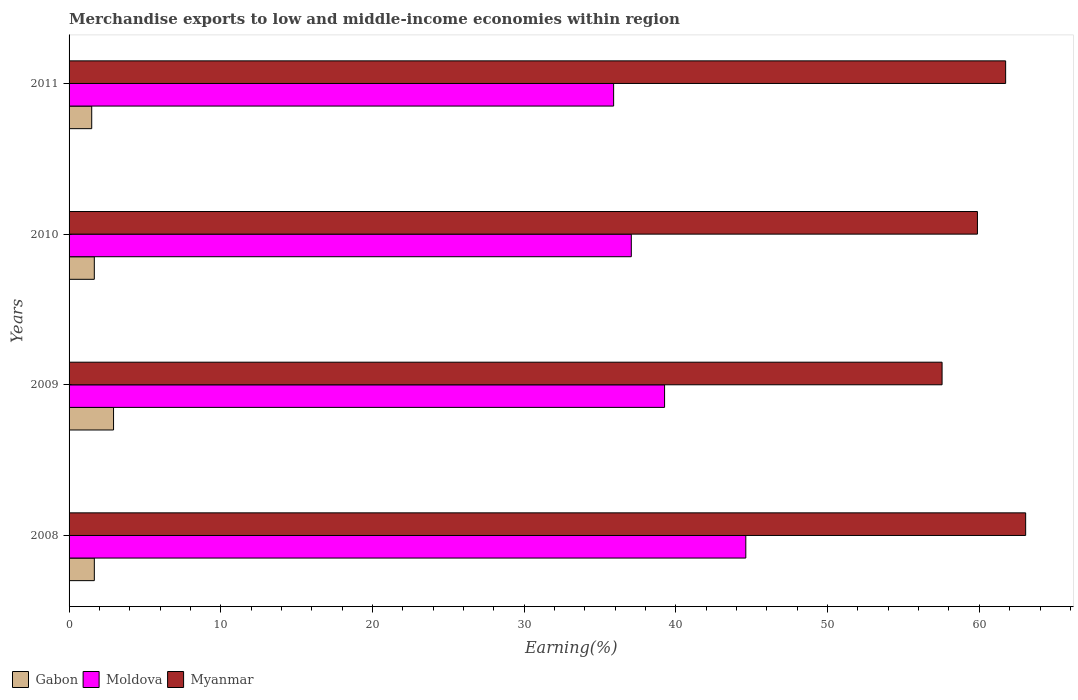How many different coloured bars are there?
Offer a terse response. 3. How many groups of bars are there?
Keep it short and to the point. 4. Are the number of bars per tick equal to the number of legend labels?
Give a very brief answer. Yes. How many bars are there on the 3rd tick from the top?
Keep it short and to the point. 3. In how many cases, is the number of bars for a given year not equal to the number of legend labels?
Give a very brief answer. 0. What is the percentage of amount earned from merchandise exports in Gabon in 2010?
Make the answer very short. 1.66. Across all years, what is the maximum percentage of amount earned from merchandise exports in Moldova?
Offer a terse response. 44.61. Across all years, what is the minimum percentage of amount earned from merchandise exports in Moldova?
Keep it short and to the point. 35.89. In which year was the percentage of amount earned from merchandise exports in Gabon minimum?
Provide a succinct answer. 2011. What is the total percentage of amount earned from merchandise exports in Myanmar in the graph?
Your response must be concise. 242.21. What is the difference between the percentage of amount earned from merchandise exports in Gabon in 2009 and that in 2011?
Keep it short and to the point. 1.44. What is the difference between the percentage of amount earned from merchandise exports in Moldova in 2010 and the percentage of amount earned from merchandise exports in Myanmar in 2011?
Your response must be concise. -24.67. What is the average percentage of amount earned from merchandise exports in Moldova per year?
Provide a succinct answer. 39.2. In the year 2009, what is the difference between the percentage of amount earned from merchandise exports in Gabon and percentage of amount earned from merchandise exports in Myanmar?
Make the answer very short. -54.61. What is the ratio of the percentage of amount earned from merchandise exports in Moldova in 2008 to that in 2009?
Provide a short and direct response. 1.14. Is the difference between the percentage of amount earned from merchandise exports in Gabon in 2008 and 2010 greater than the difference between the percentage of amount earned from merchandise exports in Myanmar in 2008 and 2010?
Your answer should be compact. No. What is the difference between the highest and the second highest percentage of amount earned from merchandise exports in Moldova?
Keep it short and to the point. 5.36. What is the difference between the highest and the lowest percentage of amount earned from merchandise exports in Myanmar?
Give a very brief answer. 5.51. In how many years, is the percentage of amount earned from merchandise exports in Gabon greater than the average percentage of amount earned from merchandise exports in Gabon taken over all years?
Offer a terse response. 1. What does the 2nd bar from the top in 2011 represents?
Provide a succinct answer. Moldova. What does the 2nd bar from the bottom in 2009 represents?
Make the answer very short. Moldova. Are all the bars in the graph horizontal?
Offer a terse response. Yes. How many years are there in the graph?
Your answer should be compact. 4. What is the difference between two consecutive major ticks on the X-axis?
Provide a short and direct response. 10. Are the values on the major ticks of X-axis written in scientific E-notation?
Ensure brevity in your answer.  No. Does the graph contain any zero values?
Provide a succinct answer. No. Does the graph contain grids?
Your response must be concise. No. Where does the legend appear in the graph?
Offer a very short reply. Bottom left. How many legend labels are there?
Provide a succinct answer. 3. What is the title of the graph?
Provide a succinct answer. Merchandise exports to low and middle-income economies within region. Does "Peru" appear as one of the legend labels in the graph?
Provide a succinct answer. No. What is the label or title of the X-axis?
Make the answer very short. Earning(%). What is the label or title of the Y-axis?
Make the answer very short. Years. What is the Earning(%) in Gabon in 2008?
Ensure brevity in your answer.  1.67. What is the Earning(%) in Moldova in 2008?
Offer a terse response. 44.61. What is the Earning(%) in Myanmar in 2008?
Provide a short and direct response. 63.05. What is the Earning(%) of Gabon in 2009?
Your response must be concise. 2.93. What is the Earning(%) of Moldova in 2009?
Keep it short and to the point. 39.25. What is the Earning(%) in Myanmar in 2009?
Ensure brevity in your answer.  57.55. What is the Earning(%) in Gabon in 2010?
Offer a terse response. 1.66. What is the Earning(%) in Moldova in 2010?
Your answer should be compact. 37.06. What is the Earning(%) of Myanmar in 2010?
Your answer should be compact. 59.88. What is the Earning(%) of Gabon in 2011?
Keep it short and to the point. 1.49. What is the Earning(%) of Moldova in 2011?
Provide a succinct answer. 35.89. What is the Earning(%) in Myanmar in 2011?
Give a very brief answer. 61.73. Across all years, what is the maximum Earning(%) of Gabon?
Your answer should be compact. 2.93. Across all years, what is the maximum Earning(%) of Moldova?
Provide a succinct answer. 44.61. Across all years, what is the maximum Earning(%) in Myanmar?
Offer a very short reply. 63.05. Across all years, what is the minimum Earning(%) of Gabon?
Provide a short and direct response. 1.49. Across all years, what is the minimum Earning(%) in Moldova?
Provide a succinct answer. 35.89. Across all years, what is the minimum Earning(%) of Myanmar?
Keep it short and to the point. 57.55. What is the total Earning(%) of Gabon in the graph?
Your answer should be very brief. 7.75. What is the total Earning(%) in Moldova in the graph?
Keep it short and to the point. 156.82. What is the total Earning(%) in Myanmar in the graph?
Your answer should be very brief. 242.21. What is the difference between the Earning(%) in Gabon in 2008 and that in 2009?
Make the answer very short. -1.27. What is the difference between the Earning(%) in Moldova in 2008 and that in 2009?
Make the answer very short. 5.36. What is the difference between the Earning(%) of Myanmar in 2008 and that in 2009?
Provide a short and direct response. 5.51. What is the difference between the Earning(%) of Gabon in 2008 and that in 2010?
Your answer should be very brief. 0. What is the difference between the Earning(%) of Moldova in 2008 and that in 2010?
Give a very brief answer. 7.55. What is the difference between the Earning(%) in Myanmar in 2008 and that in 2010?
Your answer should be compact. 3.18. What is the difference between the Earning(%) in Gabon in 2008 and that in 2011?
Your answer should be very brief. 0.17. What is the difference between the Earning(%) in Moldova in 2008 and that in 2011?
Make the answer very short. 8.71. What is the difference between the Earning(%) in Myanmar in 2008 and that in 2011?
Your answer should be very brief. 1.32. What is the difference between the Earning(%) of Gabon in 2009 and that in 2010?
Provide a succinct answer. 1.27. What is the difference between the Earning(%) in Moldova in 2009 and that in 2010?
Provide a succinct answer. 2.19. What is the difference between the Earning(%) of Myanmar in 2009 and that in 2010?
Your response must be concise. -2.33. What is the difference between the Earning(%) in Gabon in 2009 and that in 2011?
Offer a very short reply. 1.44. What is the difference between the Earning(%) in Moldova in 2009 and that in 2011?
Your response must be concise. 3.36. What is the difference between the Earning(%) in Myanmar in 2009 and that in 2011?
Make the answer very short. -4.19. What is the difference between the Earning(%) of Gabon in 2010 and that in 2011?
Your answer should be compact. 0.17. What is the difference between the Earning(%) in Moldova in 2010 and that in 2011?
Offer a very short reply. 1.17. What is the difference between the Earning(%) in Myanmar in 2010 and that in 2011?
Offer a very short reply. -1.86. What is the difference between the Earning(%) in Gabon in 2008 and the Earning(%) in Moldova in 2009?
Give a very brief answer. -37.59. What is the difference between the Earning(%) of Gabon in 2008 and the Earning(%) of Myanmar in 2009?
Provide a succinct answer. -55.88. What is the difference between the Earning(%) of Moldova in 2008 and the Earning(%) of Myanmar in 2009?
Your response must be concise. -12.94. What is the difference between the Earning(%) of Gabon in 2008 and the Earning(%) of Moldova in 2010?
Your response must be concise. -35.4. What is the difference between the Earning(%) in Gabon in 2008 and the Earning(%) in Myanmar in 2010?
Your answer should be compact. -58.21. What is the difference between the Earning(%) in Moldova in 2008 and the Earning(%) in Myanmar in 2010?
Provide a succinct answer. -15.27. What is the difference between the Earning(%) in Gabon in 2008 and the Earning(%) in Moldova in 2011?
Your answer should be compact. -34.23. What is the difference between the Earning(%) in Gabon in 2008 and the Earning(%) in Myanmar in 2011?
Give a very brief answer. -60.07. What is the difference between the Earning(%) in Moldova in 2008 and the Earning(%) in Myanmar in 2011?
Offer a very short reply. -17.13. What is the difference between the Earning(%) in Gabon in 2009 and the Earning(%) in Moldova in 2010?
Your response must be concise. -34.13. What is the difference between the Earning(%) of Gabon in 2009 and the Earning(%) of Myanmar in 2010?
Provide a short and direct response. -56.94. What is the difference between the Earning(%) of Moldova in 2009 and the Earning(%) of Myanmar in 2010?
Provide a succinct answer. -20.62. What is the difference between the Earning(%) of Gabon in 2009 and the Earning(%) of Moldova in 2011?
Make the answer very short. -32.96. What is the difference between the Earning(%) in Gabon in 2009 and the Earning(%) in Myanmar in 2011?
Ensure brevity in your answer.  -58.8. What is the difference between the Earning(%) in Moldova in 2009 and the Earning(%) in Myanmar in 2011?
Give a very brief answer. -22.48. What is the difference between the Earning(%) of Gabon in 2010 and the Earning(%) of Moldova in 2011?
Keep it short and to the point. -34.23. What is the difference between the Earning(%) in Gabon in 2010 and the Earning(%) in Myanmar in 2011?
Offer a very short reply. -60.07. What is the difference between the Earning(%) of Moldova in 2010 and the Earning(%) of Myanmar in 2011?
Provide a succinct answer. -24.67. What is the average Earning(%) of Gabon per year?
Offer a very short reply. 1.94. What is the average Earning(%) of Moldova per year?
Your answer should be compact. 39.2. What is the average Earning(%) in Myanmar per year?
Your response must be concise. 60.55. In the year 2008, what is the difference between the Earning(%) in Gabon and Earning(%) in Moldova?
Your answer should be very brief. -42.94. In the year 2008, what is the difference between the Earning(%) of Gabon and Earning(%) of Myanmar?
Make the answer very short. -61.39. In the year 2008, what is the difference between the Earning(%) of Moldova and Earning(%) of Myanmar?
Offer a very short reply. -18.45. In the year 2009, what is the difference between the Earning(%) in Gabon and Earning(%) in Moldova?
Ensure brevity in your answer.  -36.32. In the year 2009, what is the difference between the Earning(%) of Gabon and Earning(%) of Myanmar?
Keep it short and to the point. -54.61. In the year 2009, what is the difference between the Earning(%) in Moldova and Earning(%) in Myanmar?
Provide a short and direct response. -18.29. In the year 2010, what is the difference between the Earning(%) in Gabon and Earning(%) in Moldova?
Give a very brief answer. -35.4. In the year 2010, what is the difference between the Earning(%) of Gabon and Earning(%) of Myanmar?
Offer a very short reply. -58.21. In the year 2010, what is the difference between the Earning(%) of Moldova and Earning(%) of Myanmar?
Offer a very short reply. -22.82. In the year 2011, what is the difference between the Earning(%) of Gabon and Earning(%) of Moldova?
Give a very brief answer. -34.4. In the year 2011, what is the difference between the Earning(%) in Gabon and Earning(%) in Myanmar?
Offer a very short reply. -60.24. In the year 2011, what is the difference between the Earning(%) of Moldova and Earning(%) of Myanmar?
Keep it short and to the point. -25.84. What is the ratio of the Earning(%) in Gabon in 2008 to that in 2009?
Offer a terse response. 0.57. What is the ratio of the Earning(%) in Moldova in 2008 to that in 2009?
Make the answer very short. 1.14. What is the ratio of the Earning(%) of Myanmar in 2008 to that in 2009?
Your response must be concise. 1.1. What is the ratio of the Earning(%) of Gabon in 2008 to that in 2010?
Your response must be concise. 1. What is the ratio of the Earning(%) of Moldova in 2008 to that in 2010?
Your answer should be compact. 1.2. What is the ratio of the Earning(%) of Myanmar in 2008 to that in 2010?
Your answer should be very brief. 1.05. What is the ratio of the Earning(%) of Gabon in 2008 to that in 2011?
Make the answer very short. 1.12. What is the ratio of the Earning(%) in Moldova in 2008 to that in 2011?
Offer a terse response. 1.24. What is the ratio of the Earning(%) of Myanmar in 2008 to that in 2011?
Provide a short and direct response. 1.02. What is the ratio of the Earning(%) in Gabon in 2009 to that in 2010?
Keep it short and to the point. 1.76. What is the ratio of the Earning(%) in Moldova in 2009 to that in 2010?
Your answer should be very brief. 1.06. What is the ratio of the Earning(%) of Myanmar in 2009 to that in 2010?
Offer a terse response. 0.96. What is the ratio of the Earning(%) in Gabon in 2009 to that in 2011?
Offer a very short reply. 1.96. What is the ratio of the Earning(%) of Moldova in 2009 to that in 2011?
Keep it short and to the point. 1.09. What is the ratio of the Earning(%) of Myanmar in 2009 to that in 2011?
Give a very brief answer. 0.93. What is the ratio of the Earning(%) of Gabon in 2010 to that in 2011?
Your answer should be compact. 1.11. What is the ratio of the Earning(%) in Moldova in 2010 to that in 2011?
Your answer should be very brief. 1.03. What is the ratio of the Earning(%) of Myanmar in 2010 to that in 2011?
Offer a very short reply. 0.97. What is the difference between the highest and the second highest Earning(%) of Gabon?
Your response must be concise. 1.27. What is the difference between the highest and the second highest Earning(%) in Moldova?
Provide a succinct answer. 5.36. What is the difference between the highest and the second highest Earning(%) in Myanmar?
Your response must be concise. 1.32. What is the difference between the highest and the lowest Earning(%) in Gabon?
Your response must be concise. 1.44. What is the difference between the highest and the lowest Earning(%) in Moldova?
Provide a short and direct response. 8.71. What is the difference between the highest and the lowest Earning(%) in Myanmar?
Provide a succinct answer. 5.51. 